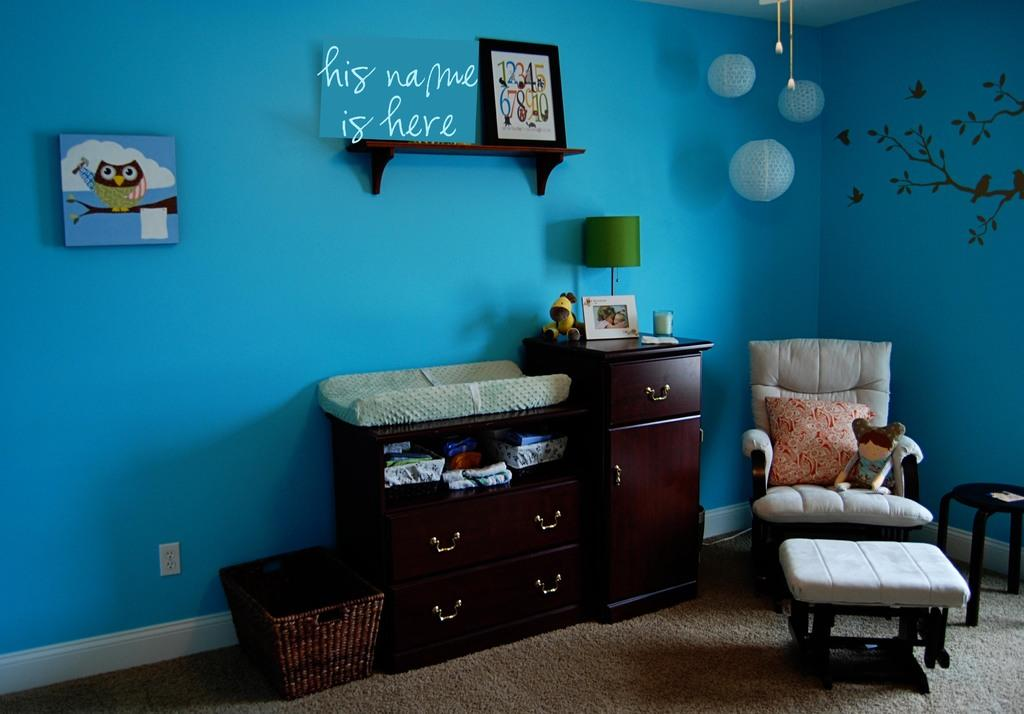<image>
Write a terse but informative summary of the picture. A blue nursery with a "his name is here" sign above the changing table 